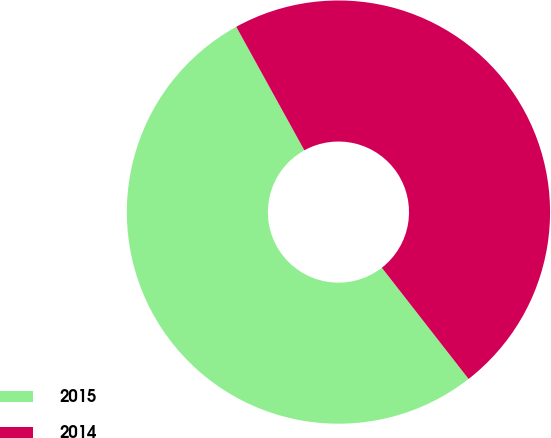Convert chart. <chart><loc_0><loc_0><loc_500><loc_500><pie_chart><fcel>2015<fcel>2014<nl><fcel>52.52%<fcel>47.48%<nl></chart> 